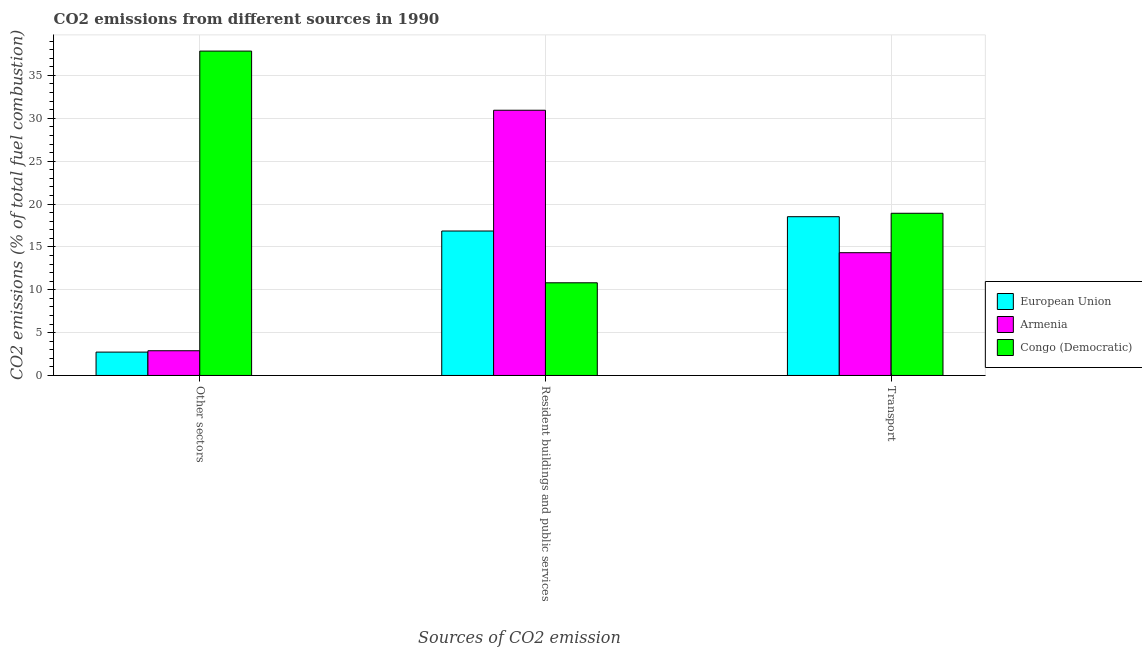How many different coloured bars are there?
Your answer should be very brief. 3. How many groups of bars are there?
Provide a short and direct response. 3. Are the number of bars per tick equal to the number of legend labels?
Provide a succinct answer. Yes. Are the number of bars on each tick of the X-axis equal?
Keep it short and to the point. Yes. How many bars are there on the 2nd tick from the left?
Your answer should be very brief. 3. What is the label of the 1st group of bars from the left?
Provide a short and direct response. Other sectors. What is the percentage of co2 emissions from other sectors in Congo (Democratic)?
Give a very brief answer. 37.84. Across all countries, what is the maximum percentage of co2 emissions from transport?
Provide a short and direct response. 18.92. Across all countries, what is the minimum percentage of co2 emissions from transport?
Ensure brevity in your answer.  14.32. In which country was the percentage of co2 emissions from resident buildings and public services maximum?
Make the answer very short. Armenia. In which country was the percentage of co2 emissions from transport minimum?
Ensure brevity in your answer.  Armenia. What is the total percentage of co2 emissions from other sectors in the graph?
Provide a short and direct response. 43.45. What is the difference between the percentage of co2 emissions from other sectors in Congo (Democratic) and that in Armenia?
Offer a very short reply. 34.95. What is the difference between the percentage of co2 emissions from other sectors in European Union and the percentage of co2 emissions from resident buildings and public services in Armenia?
Offer a terse response. -28.21. What is the average percentage of co2 emissions from resident buildings and public services per country?
Your answer should be very brief. 19.53. What is the difference between the percentage of co2 emissions from transport and percentage of co2 emissions from resident buildings and public services in Armenia?
Offer a very short reply. -16.62. What is the ratio of the percentage of co2 emissions from resident buildings and public services in Congo (Democratic) to that in Armenia?
Your response must be concise. 0.35. What is the difference between the highest and the second highest percentage of co2 emissions from other sectors?
Your answer should be very brief. 34.95. What is the difference between the highest and the lowest percentage of co2 emissions from resident buildings and public services?
Make the answer very short. 20.13. In how many countries, is the percentage of co2 emissions from resident buildings and public services greater than the average percentage of co2 emissions from resident buildings and public services taken over all countries?
Your answer should be very brief. 1. Is the sum of the percentage of co2 emissions from resident buildings and public services in European Union and Armenia greater than the maximum percentage of co2 emissions from other sectors across all countries?
Offer a terse response. Yes. What does the 1st bar from the left in Transport represents?
Offer a terse response. European Union. What does the 2nd bar from the right in Resident buildings and public services represents?
Your answer should be very brief. Armenia. Is it the case that in every country, the sum of the percentage of co2 emissions from other sectors and percentage of co2 emissions from resident buildings and public services is greater than the percentage of co2 emissions from transport?
Your answer should be very brief. Yes. How many bars are there?
Offer a terse response. 9. What is the difference between two consecutive major ticks on the Y-axis?
Offer a very short reply. 5. Does the graph contain any zero values?
Provide a succinct answer. No. Does the graph contain grids?
Provide a succinct answer. Yes. How are the legend labels stacked?
Offer a very short reply. Vertical. What is the title of the graph?
Your answer should be compact. CO2 emissions from different sources in 1990. Does "Guyana" appear as one of the legend labels in the graph?
Provide a short and direct response. No. What is the label or title of the X-axis?
Offer a very short reply. Sources of CO2 emission. What is the label or title of the Y-axis?
Your answer should be compact. CO2 emissions (% of total fuel combustion). What is the CO2 emissions (% of total fuel combustion) of European Union in Other sectors?
Provide a succinct answer. 2.73. What is the CO2 emissions (% of total fuel combustion) of Armenia in Other sectors?
Your response must be concise. 2.88. What is the CO2 emissions (% of total fuel combustion) of Congo (Democratic) in Other sectors?
Your response must be concise. 37.84. What is the CO2 emissions (% of total fuel combustion) of European Union in Resident buildings and public services?
Make the answer very short. 16.85. What is the CO2 emissions (% of total fuel combustion) in Armenia in Resident buildings and public services?
Offer a terse response. 30.94. What is the CO2 emissions (% of total fuel combustion) of Congo (Democratic) in Resident buildings and public services?
Ensure brevity in your answer.  10.81. What is the CO2 emissions (% of total fuel combustion) of European Union in Transport?
Provide a succinct answer. 18.52. What is the CO2 emissions (% of total fuel combustion) of Armenia in Transport?
Keep it short and to the point. 14.32. What is the CO2 emissions (% of total fuel combustion) of Congo (Democratic) in Transport?
Ensure brevity in your answer.  18.92. Across all Sources of CO2 emission, what is the maximum CO2 emissions (% of total fuel combustion) of European Union?
Ensure brevity in your answer.  18.52. Across all Sources of CO2 emission, what is the maximum CO2 emissions (% of total fuel combustion) in Armenia?
Give a very brief answer. 30.94. Across all Sources of CO2 emission, what is the maximum CO2 emissions (% of total fuel combustion) in Congo (Democratic)?
Your response must be concise. 37.84. Across all Sources of CO2 emission, what is the minimum CO2 emissions (% of total fuel combustion) in European Union?
Make the answer very short. 2.73. Across all Sources of CO2 emission, what is the minimum CO2 emissions (% of total fuel combustion) in Armenia?
Ensure brevity in your answer.  2.88. Across all Sources of CO2 emission, what is the minimum CO2 emissions (% of total fuel combustion) of Congo (Democratic)?
Make the answer very short. 10.81. What is the total CO2 emissions (% of total fuel combustion) of European Union in the graph?
Ensure brevity in your answer.  38.1. What is the total CO2 emissions (% of total fuel combustion) of Armenia in the graph?
Keep it short and to the point. 48.14. What is the total CO2 emissions (% of total fuel combustion) in Congo (Democratic) in the graph?
Provide a succinct answer. 67.57. What is the difference between the CO2 emissions (% of total fuel combustion) in European Union in Other sectors and that in Resident buildings and public services?
Offer a very short reply. -14.13. What is the difference between the CO2 emissions (% of total fuel combustion) of Armenia in Other sectors and that in Resident buildings and public services?
Provide a short and direct response. -28.05. What is the difference between the CO2 emissions (% of total fuel combustion) of Congo (Democratic) in Other sectors and that in Resident buildings and public services?
Your response must be concise. 27.03. What is the difference between the CO2 emissions (% of total fuel combustion) of European Union in Other sectors and that in Transport?
Your answer should be compact. -15.79. What is the difference between the CO2 emissions (% of total fuel combustion) of Armenia in Other sectors and that in Transport?
Your answer should be compact. -11.44. What is the difference between the CO2 emissions (% of total fuel combustion) of Congo (Democratic) in Other sectors and that in Transport?
Your answer should be very brief. 18.92. What is the difference between the CO2 emissions (% of total fuel combustion) in European Union in Resident buildings and public services and that in Transport?
Give a very brief answer. -1.67. What is the difference between the CO2 emissions (% of total fuel combustion) in Armenia in Resident buildings and public services and that in Transport?
Offer a terse response. 16.62. What is the difference between the CO2 emissions (% of total fuel combustion) in Congo (Democratic) in Resident buildings and public services and that in Transport?
Ensure brevity in your answer.  -8.11. What is the difference between the CO2 emissions (% of total fuel combustion) of European Union in Other sectors and the CO2 emissions (% of total fuel combustion) of Armenia in Resident buildings and public services?
Make the answer very short. -28.21. What is the difference between the CO2 emissions (% of total fuel combustion) of European Union in Other sectors and the CO2 emissions (% of total fuel combustion) of Congo (Democratic) in Resident buildings and public services?
Make the answer very short. -8.09. What is the difference between the CO2 emissions (% of total fuel combustion) of Armenia in Other sectors and the CO2 emissions (% of total fuel combustion) of Congo (Democratic) in Resident buildings and public services?
Your answer should be very brief. -7.93. What is the difference between the CO2 emissions (% of total fuel combustion) of European Union in Other sectors and the CO2 emissions (% of total fuel combustion) of Armenia in Transport?
Provide a short and direct response. -11.6. What is the difference between the CO2 emissions (% of total fuel combustion) in European Union in Other sectors and the CO2 emissions (% of total fuel combustion) in Congo (Democratic) in Transport?
Offer a very short reply. -16.19. What is the difference between the CO2 emissions (% of total fuel combustion) in Armenia in Other sectors and the CO2 emissions (% of total fuel combustion) in Congo (Democratic) in Transport?
Ensure brevity in your answer.  -16.04. What is the difference between the CO2 emissions (% of total fuel combustion) in European Union in Resident buildings and public services and the CO2 emissions (% of total fuel combustion) in Armenia in Transport?
Offer a terse response. 2.53. What is the difference between the CO2 emissions (% of total fuel combustion) of European Union in Resident buildings and public services and the CO2 emissions (% of total fuel combustion) of Congo (Democratic) in Transport?
Your response must be concise. -2.07. What is the difference between the CO2 emissions (% of total fuel combustion) of Armenia in Resident buildings and public services and the CO2 emissions (% of total fuel combustion) of Congo (Democratic) in Transport?
Offer a very short reply. 12.02. What is the average CO2 emissions (% of total fuel combustion) in European Union per Sources of CO2 emission?
Provide a succinct answer. 12.7. What is the average CO2 emissions (% of total fuel combustion) of Armenia per Sources of CO2 emission?
Ensure brevity in your answer.  16.05. What is the average CO2 emissions (% of total fuel combustion) in Congo (Democratic) per Sources of CO2 emission?
Keep it short and to the point. 22.52. What is the difference between the CO2 emissions (% of total fuel combustion) of European Union and CO2 emissions (% of total fuel combustion) of Armenia in Other sectors?
Provide a short and direct response. -0.16. What is the difference between the CO2 emissions (% of total fuel combustion) in European Union and CO2 emissions (% of total fuel combustion) in Congo (Democratic) in Other sectors?
Your response must be concise. -35.11. What is the difference between the CO2 emissions (% of total fuel combustion) of Armenia and CO2 emissions (% of total fuel combustion) of Congo (Democratic) in Other sectors?
Make the answer very short. -34.95. What is the difference between the CO2 emissions (% of total fuel combustion) in European Union and CO2 emissions (% of total fuel combustion) in Armenia in Resident buildings and public services?
Your response must be concise. -14.09. What is the difference between the CO2 emissions (% of total fuel combustion) in European Union and CO2 emissions (% of total fuel combustion) in Congo (Democratic) in Resident buildings and public services?
Provide a succinct answer. 6.04. What is the difference between the CO2 emissions (% of total fuel combustion) of Armenia and CO2 emissions (% of total fuel combustion) of Congo (Democratic) in Resident buildings and public services?
Keep it short and to the point. 20.13. What is the difference between the CO2 emissions (% of total fuel combustion) of European Union and CO2 emissions (% of total fuel combustion) of Armenia in Transport?
Offer a very short reply. 4.2. What is the difference between the CO2 emissions (% of total fuel combustion) of European Union and CO2 emissions (% of total fuel combustion) of Congo (Democratic) in Transport?
Make the answer very short. -0.4. What is the difference between the CO2 emissions (% of total fuel combustion) in Armenia and CO2 emissions (% of total fuel combustion) in Congo (Democratic) in Transport?
Make the answer very short. -4.6. What is the ratio of the CO2 emissions (% of total fuel combustion) of European Union in Other sectors to that in Resident buildings and public services?
Your answer should be compact. 0.16. What is the ratio of the CO2 emissions (% of total fuel combustion) in Armenia in Other sectors to that in Resident buildings and public services?
Your response must be concise. 0.09. What is the ratio of the CO2 emissions (% of total fuel combustion) in European Union in Other sectors to that in Transport?
Offer a very short reply. 0.15. What is the ratio of the CO2 emissions (% of total fuel combustion) of Armenia in Other sectors to that in Transport?
Give a very brief answer. 0.2. What is the ratio of the CO2 emissions (% of total fuel combustion) of European Union in Resident buildings and public services to that in Transport?
Make the answer very short. 0.91. What is the ratio of the CO2 emissions (% of total fuel combustion) in Armenia in Resident buildings and public services to that in Transport?
Offer a terse response. 2.16. What is the difference between the highest and the second highest CO2 emissions (% of total fuel combustion) of European Union?
Keep it short and to the point. 1.67. What is the difference between the highest and the second highest CO2 emissions (% of total fuel combustion) of Armenia?
Your answer should be compact. 16.62. What is the difference between the highest and the second highest CO2 emissions (% of total fuel combustion) of Congo (Democratic)?
Your answer should be compact. 18.92. What is the difference between the highest and the lowest CO2 emissions (% of total fuel combustion) of European Union?
Your response must be concise. 15.79. What is the difference between the highest and the lowest CO2 emissions (% of total fuel combustion) of Armenia?
Ensure brevity in your answer.  28.05. What is the difference between the highest and the lowest CO2 emissions (% of total fuel combustion) in Congo (Democratic)?
Your response must be concise. 27.03. 